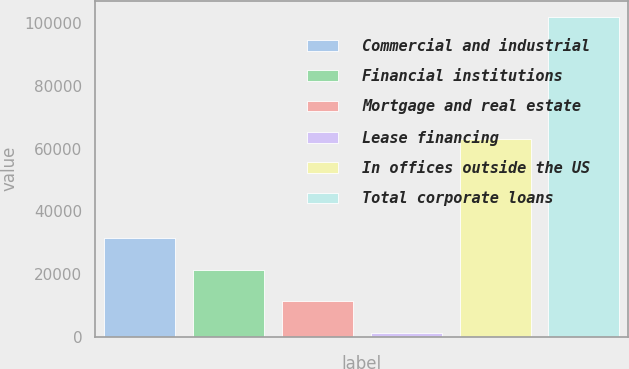<chart> <loc_0><loc_0><loc_500><loc_500><bar_chart><fcel>Commercial and industrial<fcel>Financial institutions<fcel>Mortgage and real estate<fcel>Lease financing<fcel>In offices outside the US<fcel>Total corporate loans<nl><fcel>31461.6<fcel>21365.4<fcel>11269.2<fcel>1173<fcel>63249<fcel>102135<nl></chart> 